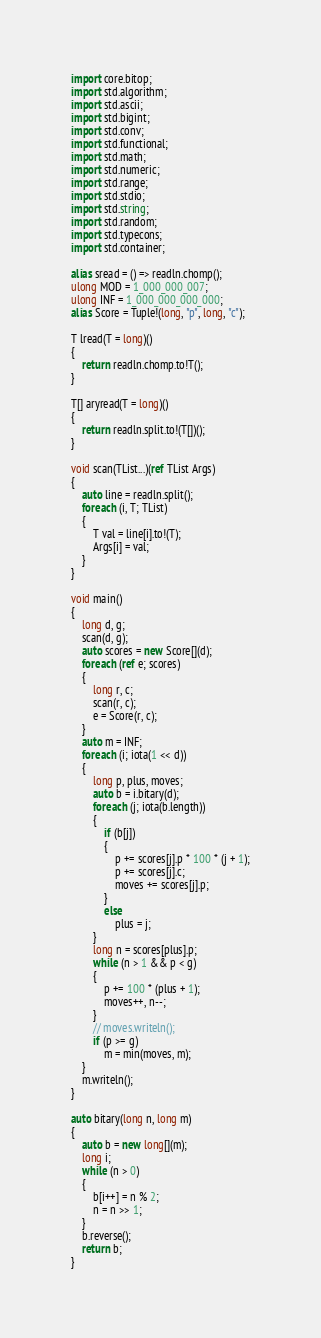Convert code to text. <code><loc_0><loc_0><loc_500><loc_500><_D_>import core.bitop;
import std.algorithm;
import std.ascii;
import std.bigint;
import std.conv;
import std.functional;
import std.math;
import std.numeric;
import std.range;
import std.stdio;
import std.string;
import std.random;
import std.typecons;
import std.container;

alias sread = () => readln.chomp();
ulong MOD = 1_000_000_007;
ulong INF = 1_000_000_000_000;
alias Score = Tuple!(long, "p", long, "c");

T lread(T = long)()
{
    return readln.chomp.to!T();
}

T[] aryread(T = long)()
{
    return readln.split.to!(T[])();
}

void scan(TList...)(ref TList Args)
{
    auto line = readln.split();
    foreach (i, T; TList)
    {
        T val = line[i].to!(T);
        Args[i] = val;
    }
}

void main()
{
    long d, g;
    scan(d, g);
    auto scores = new Score[](d);
    foreach (ref e; scores)
    {
        long r, c;
        scan(r, c);
        e = Score(r, c);
    }
    auto m = INF;
    foreach (i; iota(1 << d))
    {
        long p, plus, moves;
        auto b = i.bitary(d);
        foreach (j; iota(b.length))
        {
            if (b[j])
            {
                p += scores[j].p * 100 * (j + 1);
                p += scores[j].c;
                moves += scores[j].p;
            }
            else
                plus = j;
        }
        long n = scores[plus].p;
        while (n > 1 && p < g)
        {
            p += 100 * (plus + 1);
            moves++, n--;
        }
        // moves.writeln();
        if (p >= g)
            m = min(moves, m);
    }
    m.writeln();
}

auto bitary(long n, long m)
{
    auto b = new long[](m);
    long i;
    while (n > 0)
    {
        b[i++] = n % 2;
        n = n >> 1;
    }
    b.reverse();
    return b;
}
</code> 